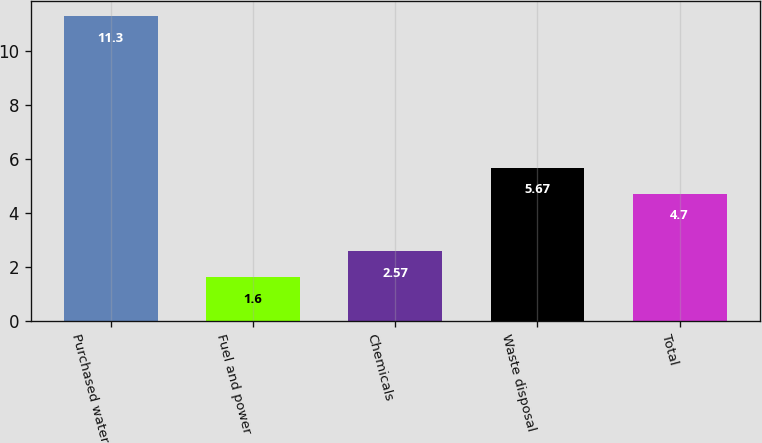<chart> <loc_0><loc_0><loc_500><loc_500><bar_chart><fcel>Purchased water<fcel>Fuel and power<fcel>Chemicals<fcel>Waste disposal<fcel>Total<nl><fcel>11.3<fcel>1.6<fcel>2.57<fcel>5.67<fcel>4.7<nl></chart> 